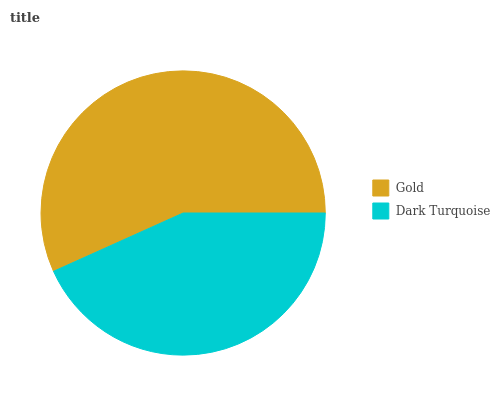Is Dark Turquoise the minimum?
Answer yes or no. Yes. Is Gold the maximum?
Answer yes or no. Yes. Is Dark Turquoise the maximum?
Answer yes or no. No. Is Gold greater than Dark Turquoise?
Answer yes or no. Yes. Is Dark Turquoise less than Gold?
Answer yes or no. Yes. Is Dark Turquoise greater than Gold?
Answer yes or no. No. Is Gold less than Dark Turquoise?
Answer yes or no. No. Is Gold the high median?
Answer yes or no. Yes. Is Dark Turquoise the low median?
Answer yes or no. Yes. Is Dark Turquoise the high median?
Answer yes or no. No. Is Gold the low median?
Answer yes or no. No. 